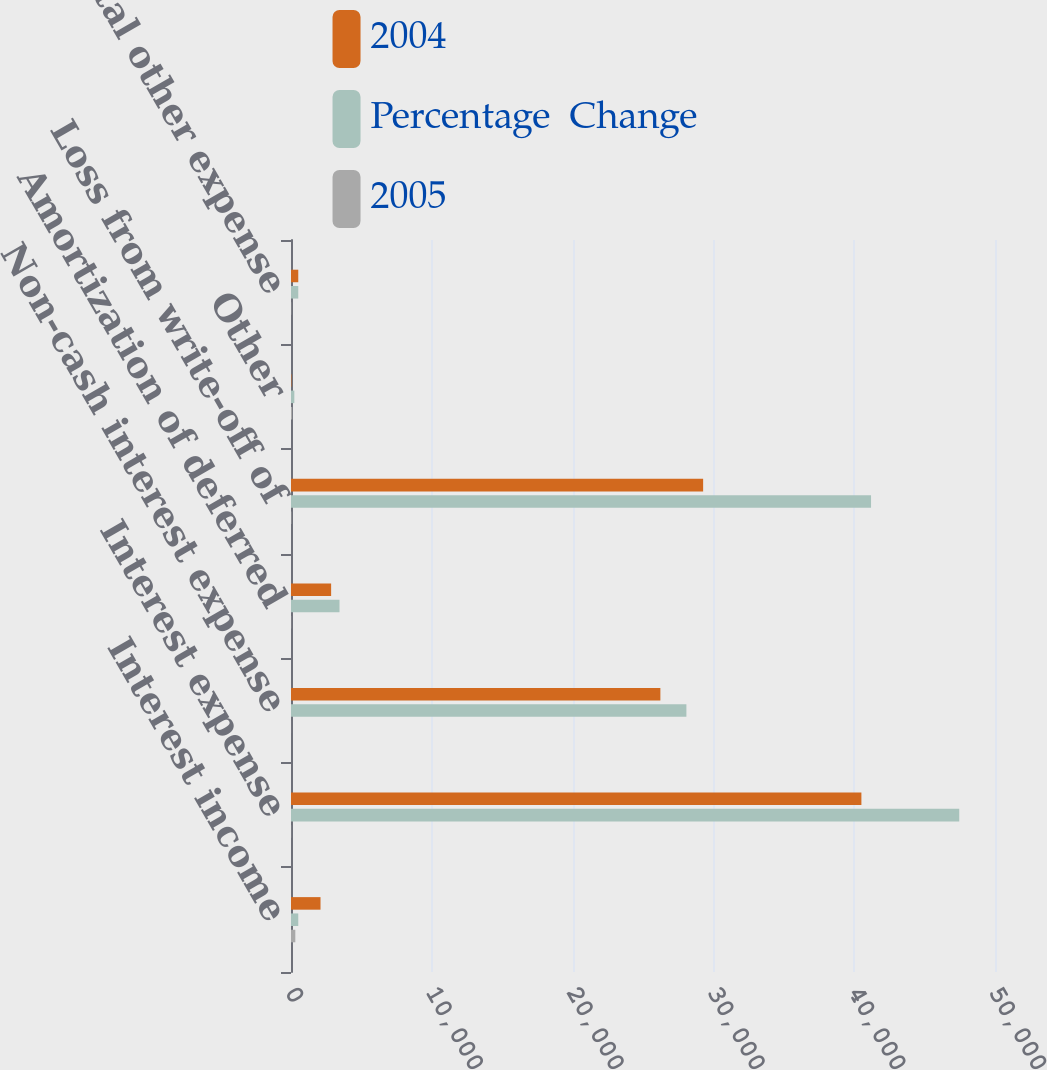<chart> <loc_0><loc_0><loc_500><loc_500><stacked_bar_chart><ecel><fcel>Interest income<fcel>Interest expense<fcel>Non-cash interest expense<fcel>Amortization of deferred<fcel>Loss from write-off of<fcel>Other<fcel>Total other expense<nl><fcel>2004<fcel>2096<fcel>40511<fcel>26234<fcel>2850<fcel>29271<fcel>31<fcel>516<nl><fcel>Percentage  Change<fcel>516<fcel>47460<fcel>28082<fcel>3445<fcel>41197<fcel>236<fcel>516<nl><fcel>2005<fcel>306.2<fcel>14.6<fcel>6.6<fcel>17.3<fcel>28.9<fcel>86.9<fcel>19<nl></chart> 